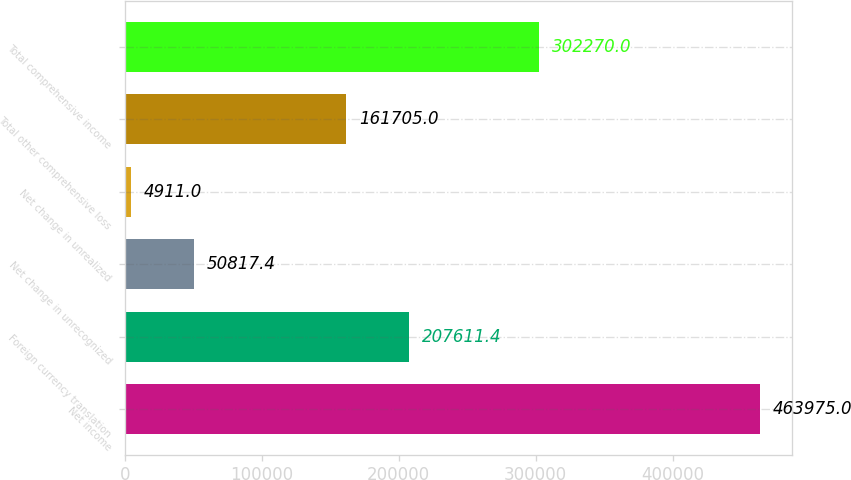Convert chart to OTSL. <chart><loc_0><loc_0><loc_500><loc_500><bar_chart><fcel>Net income<fcel>Foreign currency translation<fcel>Net change in unrecognized<fcel>Net change in unrealized<fcel>Total other comprehensive loss<fcel>Total comprehensive income<nl><fcel>463975<fcel>207611<fcel>50817.4<fcel>4911<fcel>161705<fcel>302270<nl></chart> 